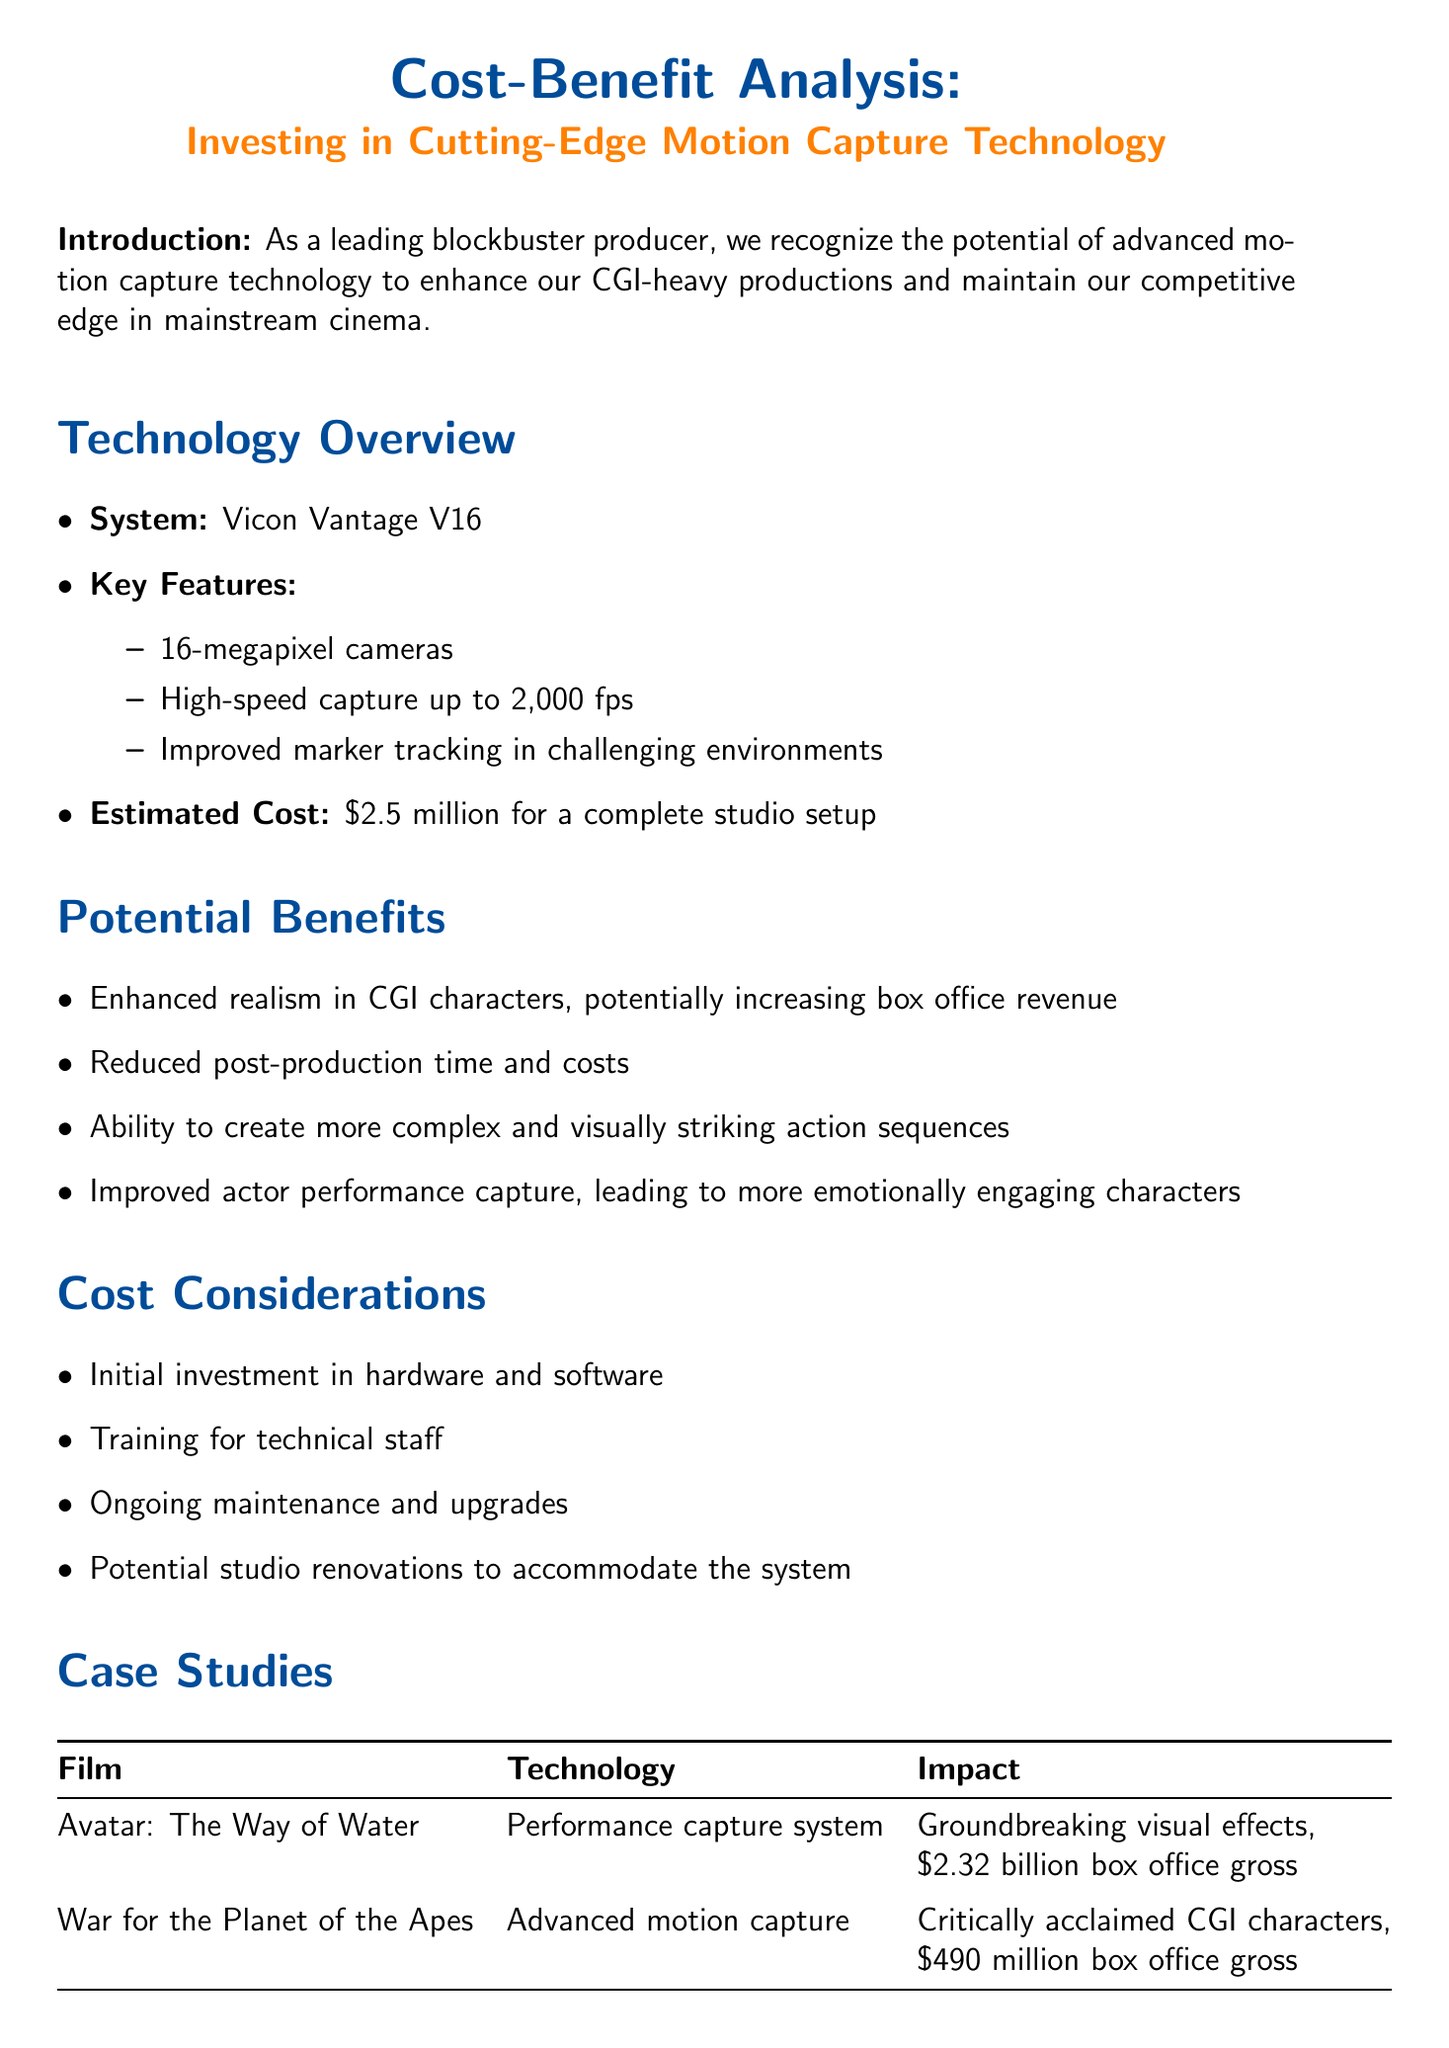What is the estimated cost for a complete studio setup? The estimated cost for a complete studio setup is stated in the technology overview section of the document.
Answer: $2.5 million What are the key features of the Vicon Vantage V16? The key features are listed in the technology overview section and include multiple specific elements.
Answer: 16-megapixel cameras, High-speed capture up to 2,000 fps, Improved marker tracking in challenging environments What is the potential revenue increase for CGI-heavy productions? This potential increase is found in the ROI projection section of the document and indicates a prospective benefit of the investment.
Answer: 15% What is the estimated cost savings in post-production efficiency? This figure is mentioned in the ROI projection section, highlighting the benefits of the investment.
Answer: $10 million Which film grossed $2.32 billion at the box office? This information is included in the case studies as an impact of the technology used in the production.
Answer: Avatar: The Way of Water What are some cost considerations mentioned in the document? The document lists several cost considerations in one of its sections, providing insight into the financial implications of the investment.
Answer: Initial investment in hardware and software, Training for technical staff, Ongoing maintenance and upgrades, Potential studio renovations What is the impact of the technology used in "War for the Planet of the Apes"? This impact is highlighted in the case studies section, which describes the effect of the advanced motion capture on the film's reception.
Answer: Critically acclaimed CGI characters Why is investing in motion capture technology considered significant? The conclusion outlines the overall view and significance of the investment in terms of financial and competitive advantage.
Answer: To enhance our blockbuster productions and potentially leading to increased box office revenue 